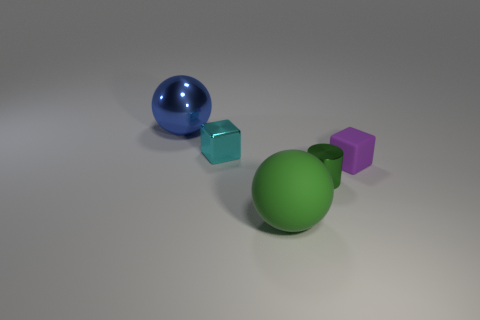Add 2 large matte spheres. How many objects exist? 7 Subtract all blue cylinders. How many blue cubes are left? 0 Subtract all gray spheres. Subtract all green objects. How many objects are left? 3 Add 3 big matte balls. How many big matte balls are left? 4 Add 1 tiny cyan things. How many tiny cyan things exist? 2 Subtract all blue spheres. How many spheres are left? 1 Subtract 1 green cylinders. How many objects are left? 4 Subtract all cubes. How many objects are left? 3 Subtract all brown cylinders. Subtract all green cubes. How many cylinders are left? 1 